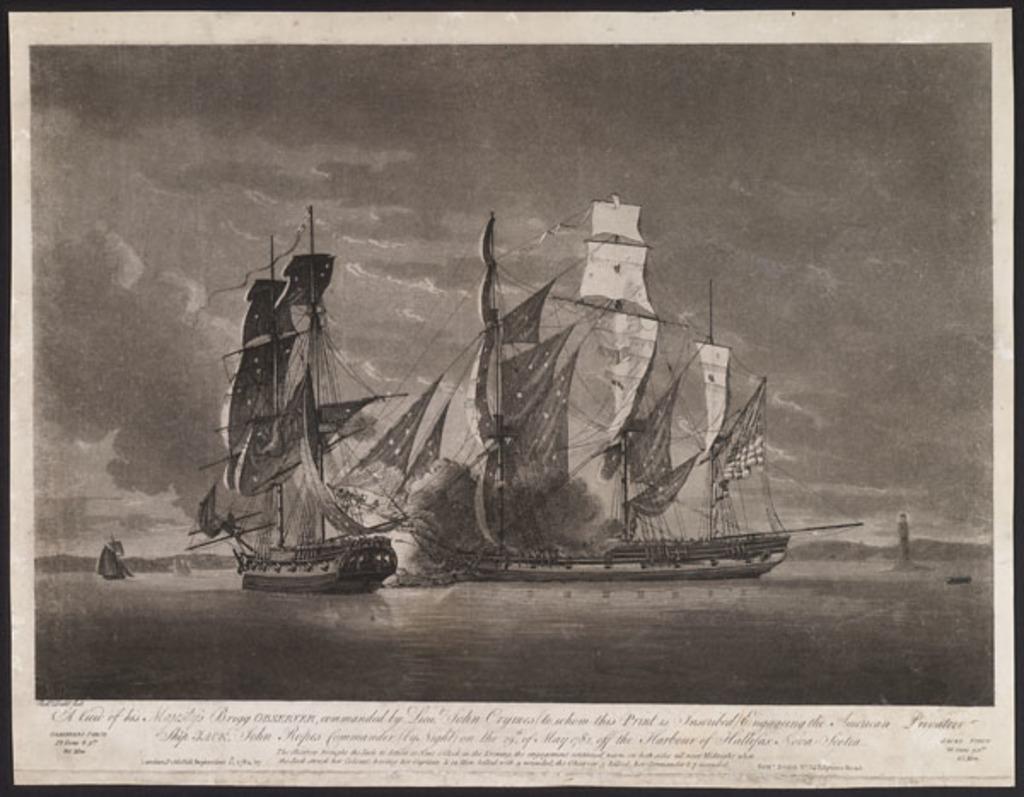Could you give a brief overview of what you see in this image? This is a black and white picture and here we can see ships on the water and in the background, there is a tree. At the bottom, there is text. 